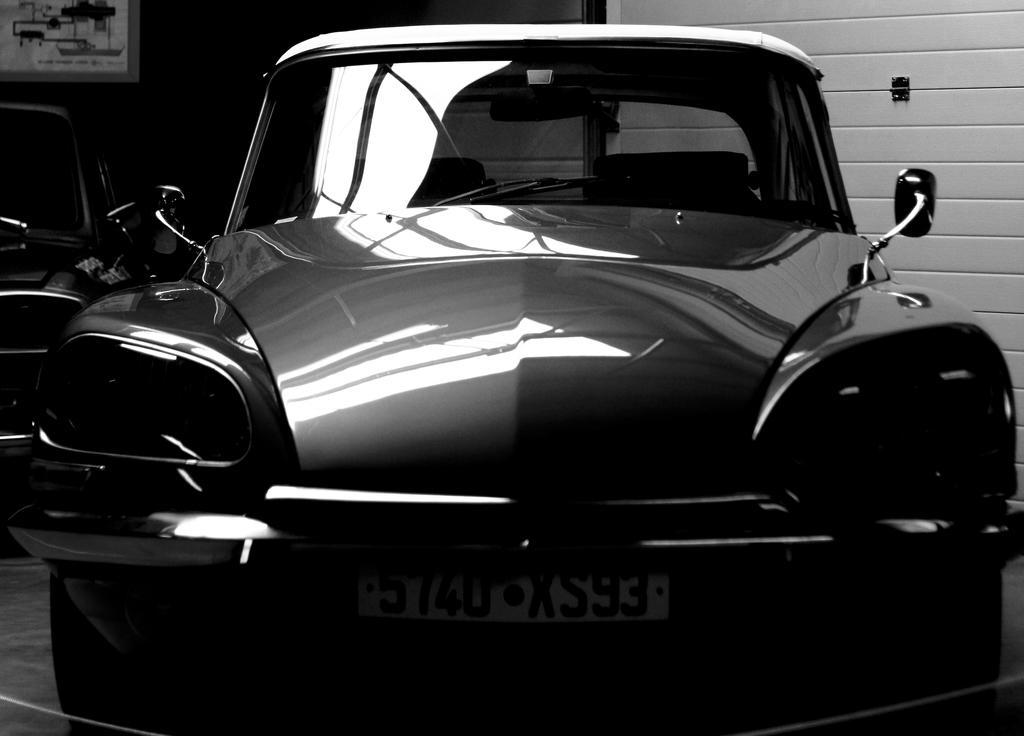Can you describe this image briefly? This is an black and white image. This picture might be taken inside the room. In this image, in the middle, we can see a car. On the right side, we can see a wall. On the left side, we can see another car. In the background, we can see a photo frame attached to a wall. 